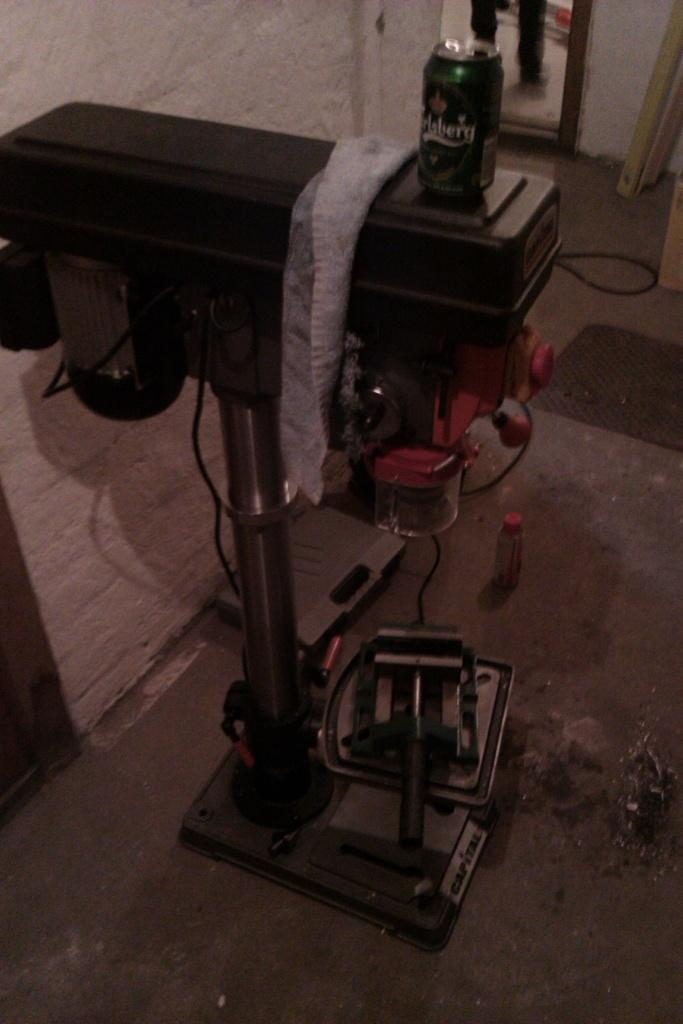<image>
Create a compact narrative representing the image presented. A can with a word on it that ends in a g is on a black surface. 